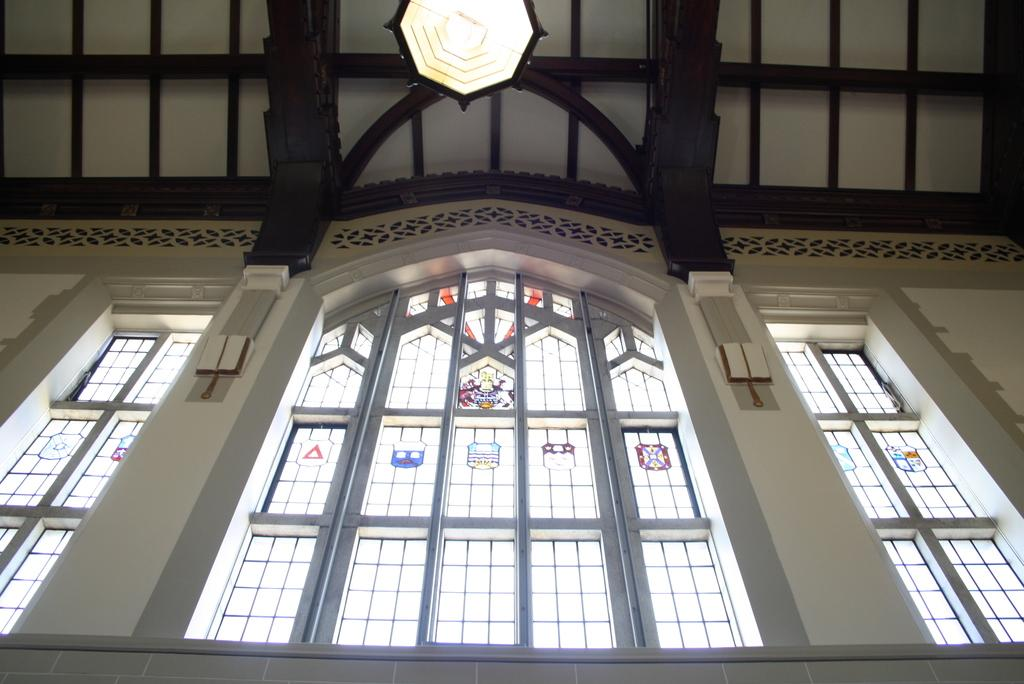What type of location is depicted in the image? The image is an inside view of a building. What architectural feature can be seen in the building? There are windows in the building. What can be seen providing illumination in the image? There is a light visible in the image. What is the uppermost part of the building in the image? There is a roof at the top of the building. What type of jam is being sold in the building in the image? There is no indication of any jam or business in the image; it is an inside view of a building with windows, a light, and a roof. 